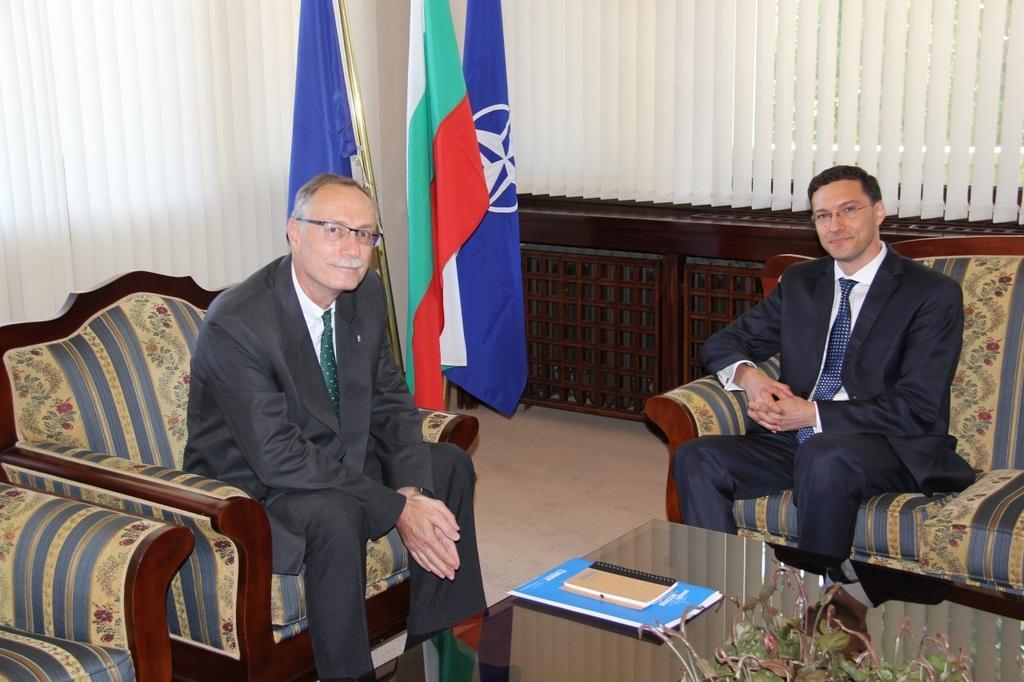Could you give a brief overview of what you see in this image? In this picture two black coat guys are sitting on the sofa and a glass table is in front of them. Notebooks , flowers are on top of it. In the background we observe national flags and curtains. 